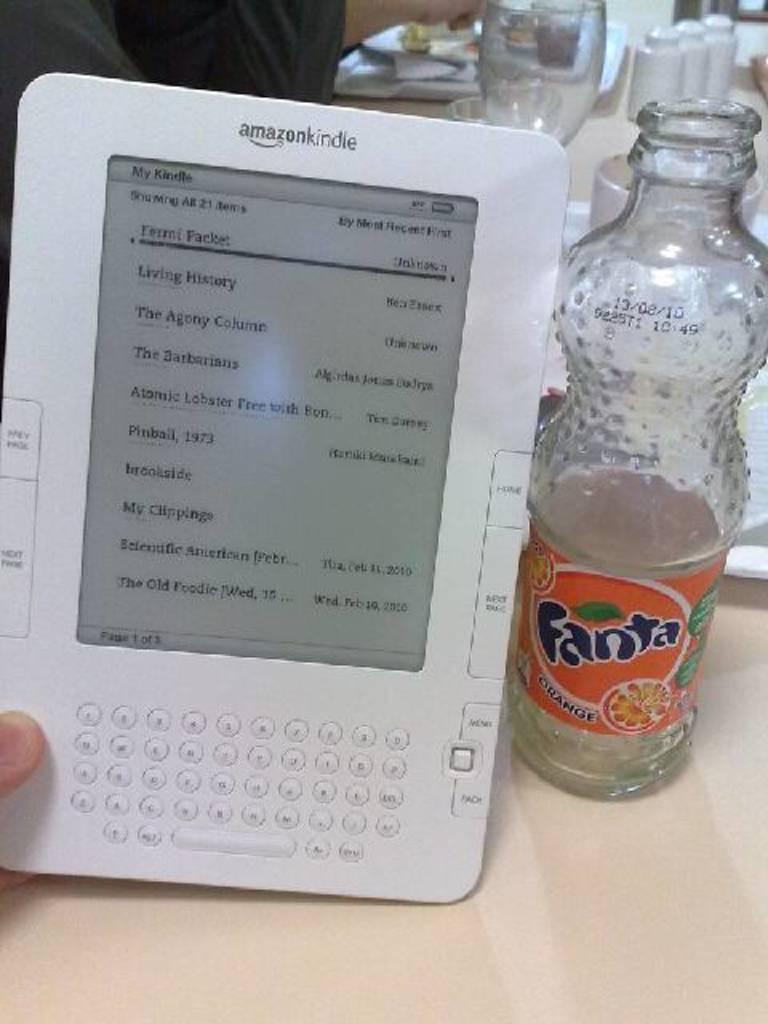What is the white device called?
Keep it short and to the point. Amazon kindle. 